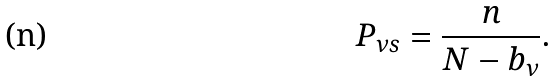Convert formula to latex. <formula><loc_0><loc_0><loc_500><loc_500>P _ { \nu s } = \frac { n } { N - b _ { \nu } } .</formula> 